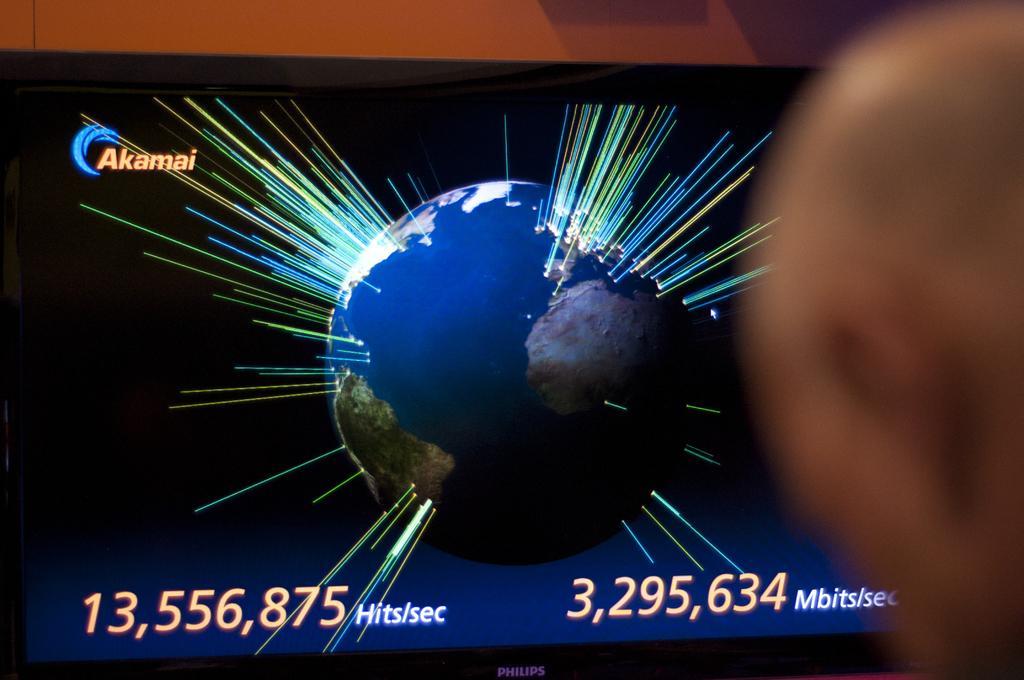Describe this image in one or two sentences. In this image I can see a television and in screen I can see earth and few numbers are written. I can also few colourful rays. 